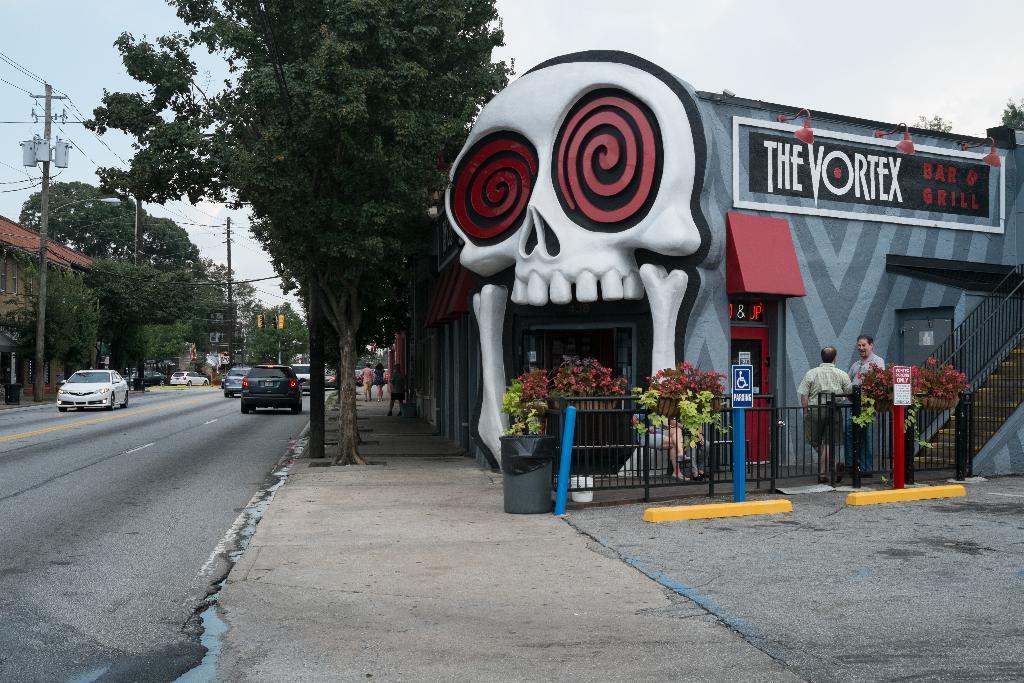How would you summarize this image in a sentence or two? In this picture, we can see a designed house with some posters, doors, fencing, plants, stairs, fencing, railing, and we can see the ground, road, vehicles, and we can see poles, wires, and we can see trees, and the sky. 